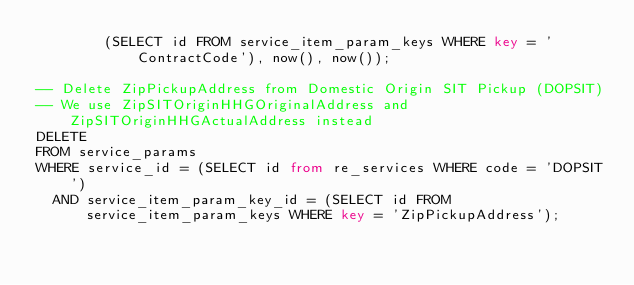Convert code to text. <code><loc_0><loc_0><loc_500><loc_500><_SQL_>        (SELECT id FROM service_item_param_keys WHERE key = 'ContractCode'), now(), now());

-- Delete ZipPickupAddress from Domestic Origin SIT Pickup (DOPSIT)
-- We use ZipSITOriginHHGOriginalAddress and ZipSITOriginHHGActualAddress instead
DELETE
FROM service_params
WHERE service_id = (SELECT id from re_services WHERE code = 'DOPSIT')
  AND service_item_param_key_id = (SELECT id FROM service_item_param_keys WHERE key = 'ZipPickupAddress');
</code> 